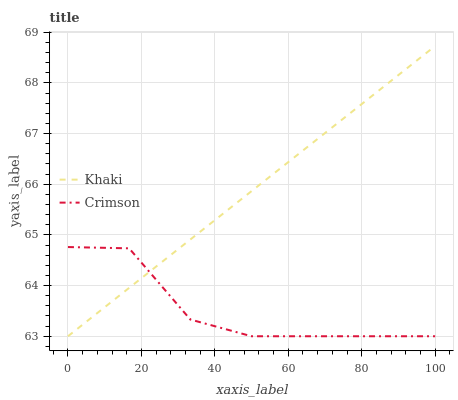Does Crimson have the minimum area under the curve?
Answer yes or no. Yes. Does Khaki have the maximum area under the curve?
Answer yes or no. Yes. Does Khaki have the minimum area under the curve?
Answer yes or no. No. Is Khaki the smoothest?
Answer yes or no. Yes. Is Crimson the roughest?
Answer yes or no. Yes. Is Khaki the roughest?
Answer yes or no. No. Does Crimson have the lowest value?
Answer yes or no. Yes. Does Khaki have the highest value?
Answer yes or no. Yes. Does Crimson intersect Khaki?
Answer yes or no. Yes. Is Crimson less than Khaki?
Answer yes or no. No. Is Crimson greater than Khaki?
Answer yes or no. No. 